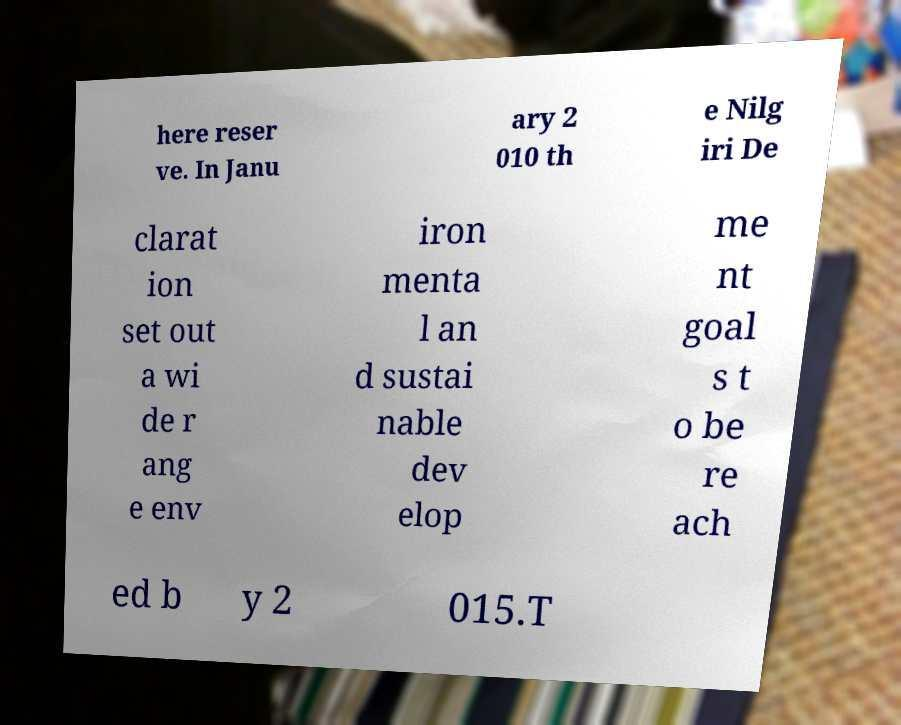There's text embedded in this image that I need extracted. Can you transcribe it verbatim? here reser ve. In Janu ary 2 010 th e Nilg iri De clarat ion set out a wi de r ang e env iron menta l an d sustai nable dev elop me nt goal s t o be re ach ed b y 2 015.T 